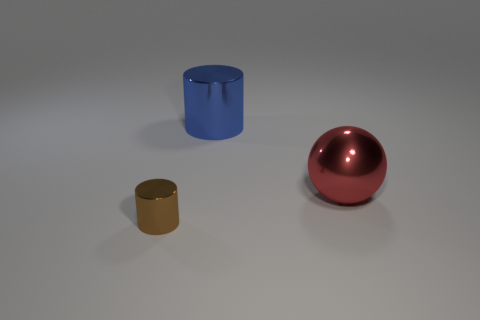Add 1 tiny gray cubes. How many objects exist? 4 Subtract all cylinders. How many objects are left? 1 Add 2 tiny cylinders. How many tiny cylinders are left? 3 Add 2 tiny metallic cylinders. How many tiny metallic cylinders exist? 3 Subtract 0 brown blocks. How many objects are left? 3 Subtract all green metal spheres. Subtract all cylinders. How many objects are left? 1 